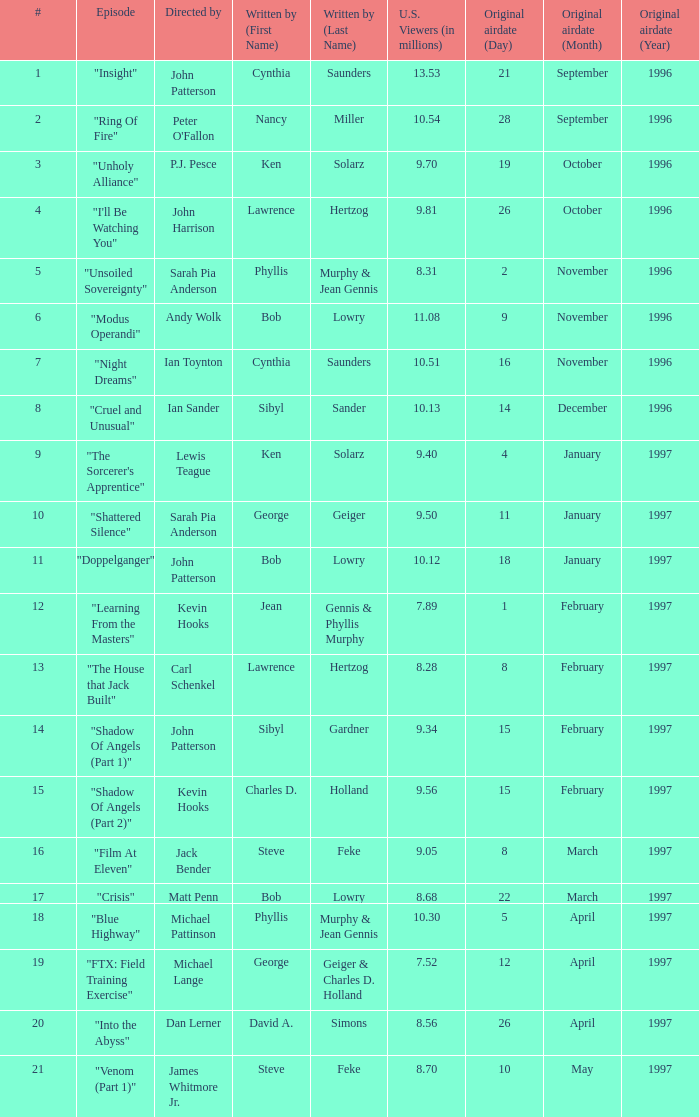Who wrote the episode with 9.81 million US viewers? Lawrence Hertzog. 